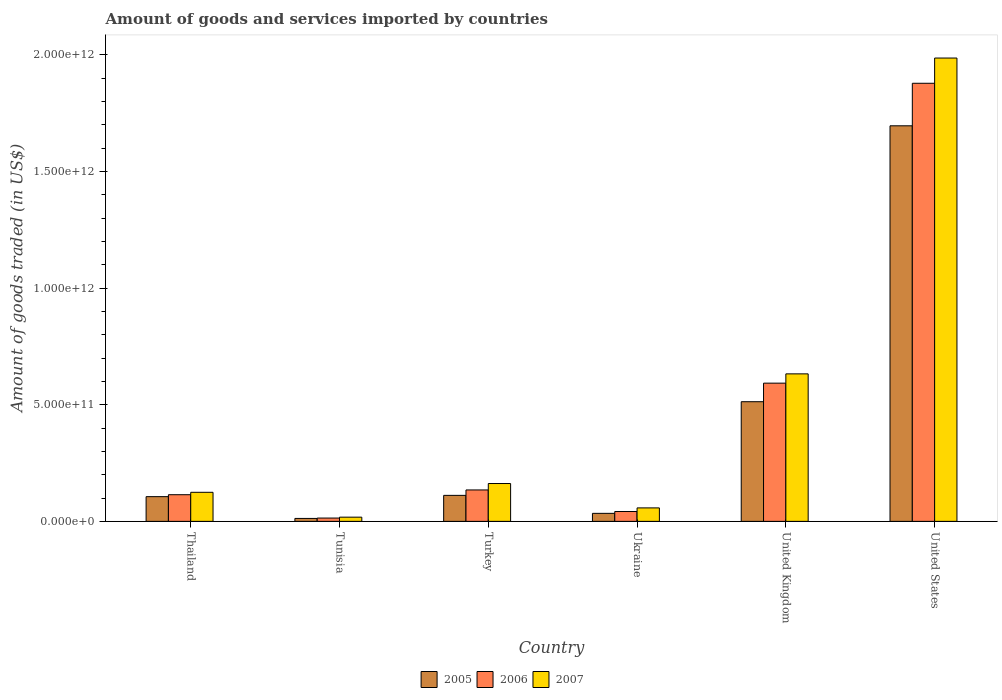How many different coloured bars are there?
Your answer should be compact. 3. Are the number of bars per tick equal to the number of legend labels?
Make the answer very short. Yes. How many bars are there on the 2nd tick from the right?
Provide a short and direct response. 3. What is the label of the 1st group of bars from the left?
Provide a short and direct response. Thailand. In how many cases, is the number of bars for a given country not equal to the number of legend labels?
Give a very brief answer. 0. What is the total amount of goods and services imported in 2007 in Ukraine?
Your response must be concise. 5.78e+1. Across all countries, what is the maximum total amount of goods and services imported in 2005?
Keep it short and to the point. 1.70e+12. Across all countries, what is the minimum total amount of goods and services imported in 2006?
Offer a very short reply. 1.42e+1. In which country was the total amount of goods and services imported in 2005 maximum?
Offer a very short reply. United States. In which country was the total amount of goods and services imported in 2007 minimum?
Your response must be concise. Tunisia. What is the total total amount of goods and services imported in 2007 in the graph?
Ensure brevity in your answer.  2.98e+12. What is the difference between the total amount of goods and services imported in 2007 in Thailand and that in United Kingdom?
Give a very brief answer. -5.08e+11. What is the difference between the total amount of goods and services imported in 2007 in United States and the total amount of goods and services imported in 2006 in Thailand?
Ensure brevity in your answer.  1.87e+12. What is the average total amount of goods and services imported in 2007 per country?
Your response must be concise. 4.97e+11. What is the difference between the total amount of goods and services imported of/in 2006 and total amount of goods and services imported of/in 2005 in United States?
Offer a terse response. 1.82e+11. In how many countries, is the total amount of goods and services imported in 2007 greater than 200000000000 US$?
Offer a terse response. 2. What is the ratio of the total amount of goods and services imported in 2006 in Thailand to that in United Kingdom?
Your response must be concise. 0.19. Is the total amount of goods and services imported in 2007 in Thailand less than that in Ukraine?
Provide a short and direct response. No. Is the difference between the total amount of goods and services imported in 2006 in Turkey and United States greater than the difference between the total amount of goods and services imported in 2005 in Turkey and United States?
Provide a short and direct response. No. What is the difference between the highest and the second highest total amount of goods and services imported in 2006?
Your response must be concise. 1.29e+12. What is the difference between the highest and the lowest total amount of goods and services imported in 2007?
Keep it short and to the point. 1.97e+12. In how many countries, is the total amount of goods and services imported in 2007 greater than the average total amount of goods and services imported in 2007 taken over all countries?
Keep it short and to the point. 2. Is the sum of the total amount of goods and services imported in 2007 in Tunisia and Turkey greater than the maximum total amount of goods and services imported in 2005 across all countries?
Your answer should be compact. No. What does the 3rd bar from the left in Thailand represents?
Provide a succinct answer. 2007. How many bars are there?
Your answer should be compact. 18. How many countries are there in the graph?
Make the answer very short. 6. What is the difference between two consecutive major ticks on the Y-axis?
Your answer should be compact. 5.00e+11. Are the values on the major ticks of Y-axis written in scientific E-notation?
Give a very brief answer. Yes. Does the graph contain grids?
Give a very brief answer. No. Where does the legend appear in the graph?
Give a very brief answer. Bottom center. What is the title of the graph?
Your response must be concise. Amount of goods and services imported by countries. What is the label or title of the Y-axis?
Ensure brevity in your answer.  Amount of goods traded (in US$). What is the Amount of goods traded (in US$) in 2005 in Thailand?
Your answer should be compact. 1.06e+11. What is the Amount of goods traded (in US$) in 2006 in Thailand?
Your response must be concise. 1.14e+11. What is the Amount of goods traded (in US$) of 2007 in Thailand?
Offer a very short reply. 1.25e+11. What is the Amount of goods traded (in US$) of 2005 in Tunisia?
Give a very brief answer. 1.26e+1. What is the Amount of goods traded (in US$) of 2006 in Tunisia?
Offer a terse response. 1.42e+1. What is the Amount of goods traded (in US$) in 2007 in Tunisia?
Keep it short and to the point. 1.80e+1. What is the Amount of goods traded (in US$) in 2005 in Turkey?
Provide a succinct answer. 1.11e+11. What is the Amount of goods traded (in US$) in 2006 in Turkey?
Your answer should be very brief. 1.35e+11. What is the Amount of goods traded (in US$) in 2007 in Turkey?
Your response must be concise. 1.62e+11. What is the Amount of goods traded (in US$) in 2005 in Ukraine?
Provide a short and direct response. 3.44e+1. What is the Amount of goods traded (in US$) of 2006 in Ukraine?
Offer a terse response. 4.22e+1. What is the Amount of goods traded (in US$) of 2007 in Ukraine?
Give a very brief answer. 5.78e+1. What is the Amount of goods traded (in US$) of 2005 in United Kingdom?
Your answer should be compact. 5.13e+11. What is the Amount of goods traded (in US$) in 2006 in United Kingdom?
Your answer should be compact. 5.93e+11. What is the Amount of goods traded (in US$) in 2007 in United Kingdom?
Ensure brevity in your answer.  6.32e+11. What is the Amount of goods traded (in US$) of 2005 in United States?
Your answer should be very brief. 1.70e+12. What is the Amount of goods traded (in US$) of 2006 in United States?
Give a very brief answer. 1.88e+12. What is the Amount of goods traded (in US$) of 2007 in United States?
Ensure brevity in your answer.  1.99e+12. Across all countries, what is the maximum Amount of goods traded (in US$) in 2005?
Provide a short and direct response. 1.70e+12. Across all countries, what is the maximum Amount of goods traded (in US$) in 2006?
Provide a succinct answer. 1.88e+12. Across all countries, what is the maximum Amount of goods traded (in US$) of 2007?
Make the answer very short. 1.99e+12. Across all countries, what is the minimum Amount of goods traded (in US$) of 2005?
Your answer should be compact. 1.26e+1. Across all countries, what is the minimum Amount of goods traded (in US$) in 2006?
Provide a succinct answer. 1.42e+1. Across all countries, what is the minimum Amount of goods traded (in US$) of 2007?
Ensure brevity in your answer.  1.80e+1. What is the total Amount of goods traded (in US$) of 2005 in the graph?
Ensure brevity in your answer.  2.47e+12. What is the total Amount of goods traded (in US$) of 2006 in the graph?
Give a very brief answer. 2.78e+12. What is the total Amount of goods traded (in US$) of 2007 in the graph?
Make the answer very short. 2.98e+12. What is the difference between the Amount of goods traded (in US$) in 2005 in Thailand and that in Tunisia?
Your response must be concise. 9.34e+1. What is the difference between the Amount of goods traded (in US$) of 2006 in Thailand and that in Tunisia?
Your response must be concise. 1.00e+11. What is the difference between the Amount of goods traded (in US$) of 2007 in Thailand and that in Tunisia?
Provide a short and direct response. 1.07e+11. What is the difference between the Amount of goods traded (in US$) in 2005 in Thailand and that in Turkey?
Make the answer very short. -5.47e+09. What is the difference between the Amount of goods traded (in US$) in 2006 in Thailand and that in Turkey?
Your answer should be compact. -2.04e+1. What is the difference between the Amount of goods traded (in US$) in 2007 in Thailand and that in Turkey?
Ensure brevity in your answer.  -3.76e+1. What is the difference between the Amount of goods traded (in US$) of 2005 in Thailand and that in Ukraine?
Ensure brevity in your answer.  7.16e+1. What is the difference between the Amount of goods traded (in US$) of 2006 in Thailand and that in Ukraine?
Your response must be concise. 7.20e+1. What is the difference between the Amount of goods traded (in US$) in 2007 in Thailand and that in Ukraine?
Make the answer very short. 6.69e+1. What is the difference between the Amount of goods traded (in US$) of 2005 in Thailand and that in United Kingdom?
Make the answer very short. -4.07e+11. What is the difference between the Amount of goods traded (in US$) of 2006 in Thailand and that in United Kingdom?
Provide a succinct answer. -4.78e+11. What is the difference between the Amount of goods traded (in US$) in 2007 in Thailand and that in United Kingdom?
Give a very brief answer. -5.08e+11. What is the difference between the Amount of goods traded (in US$) in 2005 in Thailand and that in United States?
Your response must be concise. -1.59e+12. What is the difference between the Amount of goods traded (in US$) of 2006 in Thailand and that in United States?
Offer a very short reply. -1.76e+12. What is the difference between the Amount of goods traded (in US$) of 2007 in Thailand and that in United States?
Make the answer very short. -1.86e+12. What is the difference between the Amount of goods traded (in US$) of 2005 in Tunisia and that in Turkey?
Provide a short and direct response. -9.89e+1. What is the difference between the Amount of goods traded (in US$) in 2006 in Tunisia and that in Turkey?
Provide a short and direct response. -1.20e+11. What is the difference between the Amount of goods traded (in US$) of 2007 in Tunisia and that in Turkey?
Give a very brief answer. -1.44e+11. What is the difference between the Amount of goods traded (in US$) in 2005 in Tunisia and that in Ukraine?
Your response must be concise. -2.18e+1. What is the difference between the Amount of goods traded (in US$) of 2006 in Tunisia and that in Ukraine?
Provide a succinct answer. -2.80e+1. What is the difference between the Amount of goods traded (in US$) of 2007 in Tunisia and that in Ukraine?
Give a very brief answer. -3.97e+1. What is the difference between the Amount of goods traded (in US$) of 2005 in Tunisia and that in United Kingdom?
Offer a terse response. -5.00e+11. What is the difference between the Amount of goods traded (in US$) in 2006 in Tunisia and that in United Kingdom?
Ensure brevity in your answer.  -5.78e+11. What is the difference between the Amount of goods traded (in US$) in 2007 in Tunisia and that in United Kingdom?
Your answer should be compact. -6.14e+11. What is the difference between the Amount of goods traded (in US$) in 2005 in Tunisia and that in United States?
Your answer should be compact. -1.68e+12. What is the difference between the Amount of goods traded (in US$) of 2006 in Tunisia and that in United States?
Offer a very short reply. -1.86e+12. What is the difference between the Amount of goods traded (in US$) in 2007 in Tunisia and that in United States?
Your answer should be compact. -1.97e+12. What is the difference between the Amount of goods traded (in US$) in 2005 in Turkey and that in Ukraine?
Offer a very short reply. 7.71e+1. What is the difference between the Amount of goods traded (in US$) of 2006 in Turkey and that in Ukraine?
Keep it short and to the point. 9.25e+1. What is the difference between the Amount of goods traded (in US$) of 2007 in Turkey and that in Ukraine?
Provide a short and direct response. 1.04e+11. What is the difference between the Amount of goods traded (in US$) of 2005 in Turkey and that in United Kingdom?
Offer a terse response. -4.02e+11. What is the difference between the Amount of goods traded (in US$) in 2006 in Turkey and that in United Kingdom?
Offer a terse response. -4.58e+11. What is the difference between the Amount of goods traded (in US$) in 2007 in Turkey and that in United Kingdom?
Offer a terse response. -4.70e+11. What is the difference between the Amount of goods traded (in US$) of 2005 in Turkey and that in United States?
Keep it short and to the point. -1.58e+12. What is the difference between the Amount of goods traded (in US$) of 2006 in Turkey and that in United States?
Ensure brevity in your answer.  -1.74e+12. What is the difference between the Amount of goods traded (in US$) in 2007 in Turkey and that in United States?
Provide a short and direct response. -1.82e+12. What is the difference between the Amount of goods traded (in US$) in 2005 in Ukraine and that in United Kingdom?
Ensure brevity in your answer.  -4.79e+11. What is the difference between the Amount of goods traded (in US$) in 2006 in Ukraine and that in United Kingdom?
Your answer should be compact. -5.50e+11. What is the difference between the Amount of goods traded (in US$) in 2007 in Ukraine and that in United Kingdom?
Make the answer very short. -5.75e+11. What is the difference between the Amount of goods traded (in US$) of 2005 in Ukraine and that in United States?
Ensure brevity in your answer.  -1.66e+12. What is the difference between the Amount of goods traded (in US$) of 2006 in Ukraine and that in United States?
Keep it short and to the point. -1.84e+12. What is the difference between the Amount of goods traded (in US$) of 2007 in Ukraine and that in United States?
Offer a very short reply. -1.93e+12. What is the difference between the Amount of goods traded (in US$) in 2005 in United Kingdom and that in United States?
Give a very brief answer. -1.18e+12. What is the difference between the Amount of goods traded (in US$) in 2006 in United Kingdom and that in United States?
Your answer should be compact. -1.29e+12. What is the difference between the Amount of goods traded (in US$) in 2007 in United Kingdom and that in United States?
Your answer should be very brief. -1.35e+12. What is the difference between the Amount of goods traded (in US$) in 2005 in Thailand and the Amount of goods traded (in US$) in 2006 in Tunisia?
Your response must be concise. 9.18e+1. What is the difference between the Amount of goods traded (in US$) in 2005 in Thailand and the Amount of goods traded (in US$) in 2007 in Tunisia?
Your answer should be very brief. 8.80e+1. What is the difference between the Amount of goods traded (in US$) of 2006 in Thailand and the Amount of goods traded (in US$) of 2007 in Tunisia?
Give a very brief answer. 9.62e+1. What is the difference between the Amount of goods traded (in US$) in 2005 in Thailand and the Amount of goods traded (in US$) in 2006 in Turkey?
Ensure brevity in your answer.  -2.87e+1. What is the difference between the Amount of goods traded (in US$) in 2005 in Thailand and the Amount of goods traded (in US$) in 2007 in Turkey?
Provide a succinct answer. -5.62e+1. What is the difference between the Amount of goods traded (in US$) of 2006 in Thailand and the Amount of goods traded (in US$) of 2007 in Turkey?
Ensure brevity in your answer.  -4.79e+1. What is the difference between the Amount of goods traded (in US$) of 2005 in Thailand and the Amount of goods traded (in US$) of 2006 in Ukraine?
Make the answer very short. 6.38e+1. What is the difference between the Amount of goods traded (in US$) of 2005 in Thailand and the Amount of goods traded (in US$) of 2007 in Ukraine?
Your answer should be compact. 4.82e+1. What is the difference between the Amount of goods traded (in US$) in 2006 in Thailand and the Amount of goods traded (in US$) in 2007 in Ukraine?
Ensure brevity in your answer.  5.65e+1. What is the difference between the Amount of goods traded (in US$) of 2005 in Thailand and the Amount of goods traded (in US$) of 2006 in United Kingdom?
Provide a short and direct response. -4.87e+11. What is the difference between the Amount of goods traded (in US$) of 2005 in Thailand and the Amount of goods traded (in US$) of 2007 in United Kingdom?
Your answer should be compact. -5.26e+11. What is the difference between the Amount of goods traded (in US$) in 2006 in Thailand and the Amount of goods traded (in US$) in 2007 in United Kingdom?
Offer a terse response. -5.18e+11. What is the difference between the Amount of goods traded (in US$) in 2005 in Thailand and the Amount of goods traded (in US$) in 2006 in United States?
Make the answer very short. -1.77e+12. What is the difference between the Amount of goods traded (in US$) of 2005 in Thailand and the Amount of goods traded (in US$) of 2007 in United States?
Provide a short and direct response. -1.88e+12. What is the difference between the Amount of goods traded (in US$) in 2006 in Thailand and the Amount of goods traded (in US$) in 2007 in United States?
Make the answer very short. -1.87e+12. What is the difference between the Amount of goods traded (in US$) of 2005 in Tunisia and the Amount of goods traded (in US$) of 2006 in Turkey?
Offer a terse response. -1.22e+11. What is the difference between the Amount of goods traded (in US$) of 2005 in Tunisia and the Amount of goods traded (in US$) of 2007 in Turkey?
Provide a short and direct response. -1.50e+11. What is the difference between the Amount of goods traded (in US$) in 2006 in Tunisia and the Amount of goods traded (in US$) in 2007 in Turkey?
Provide a short and direct response. -1.48e+11. What is the difference between the Amount of goods traded (in US$) in 2005 in Tunisia and the Amount of goods traded (in US$) in 2006 in Ukraine?
Give a very brief answer. -2.96e+1. What is the difference between the Amount of goods traded (in US$) in 2005 in Tunisia and the Amount of goods traded (in US$) in 2007 in Ukraine?
Make the answer very short. -4.52e+1. What is the difference between the Amount of goods traded (in US$) in 2006 in Tunisia and the Amount of goods traded (in US$) in 2007 in Ukraine?
Keep it short and to the point. -4.36e+1. What is the difference between the Amount of goods traded (in US$) in 2005 in Tunisia and the Amount of goods traded (in US$) in 2006 in United Kingdom?
Keep it short and to the point. -5.80e+11. What is the difference between the Amount of goods traded (in US$) of 2005 in Tunisia and the Amount of goods traded (in US$) of 2007 in United Kingdom?
Your response must be concise. -6.20e+11. What is the difference between the Amount of goods traded (in US$) in 2006 in Tunisia and the Amount of goods traded (in US$) in 2007 in United Kingdom?
Your answer should be very brief. -6.18e+11. What is the difference between the Amount of goods traded (in US$) in 2005 in Tunisia and the Amount of goods traded (in US$) in 2006 in United States?
Your answer should be compact. -1.87e+12. What is the difference between the Amount of goods traded (in US$) of 2005 in Tunisia and the Amount of goods traded (in US$) of 2007 in United States?
Give a very brief answer. -1.97e+12. What is the difference between the Amount of goods traded (in US$) in 2006 in Tunisia and the Amount of goods traded (in US$) in 2007 in United States?
Give a very brief answer. -1.97e+12. What is the difference between the Amount of goods traded (in US$) of 2005 in Turkey and the Amount of goods traded (in US$) of 2006 in Ukraine?
Make the answer very short. 6.92e+1. What is the difference between the Amount of goods traded (in US$) in 2005 in Turkey and the Amount of goods traded (in US$) in 2007 in Ukraine?
Make the answer very short. 5.37e+1. What is the difference between the Amount of goods traded (in US$) in 2006 in Turkey and the Amount of goods traded (in US$) in 2007 in Ukraine?
Ensure brevity in your answer.  7.69e+1. What is the difference between the Amount of goods traded (in US$) of 2005 in Turkey and the Amount of goods traded (in US$) of 2006 in United Kingdom?
Offer a very short reply. -4.81e+11. What is the difference between the Amount of goods traded (in US$) in 2005 in Turkey and the Amount of goods traded (in US$) in 2007 in United Kingdom?
Your response must be concise. -5.21e+11. What is the difference between the Amount of goods traded (in US$) of 2006 in Turkey and the Amount of goods traded (in US$) of 2007 in United Kingdom?
Provide a succinct answer. -4.98e+11. What is the difference between the Amount of goods traded (in US$) in 2005 in Turkey and the Amount of goods traded (in US$) in 2006 in United States?
Your response must be concise. -1.77e+12. What is the difference between the Amount of goods traded (in US$) in 2005 in Turkey and the Amount of goods traded (in US$) in 2007 in United States?
Give a very brief answer. -1.87e+12. What is the difference between the Amount of goods traded (in US$) in 2006 in Turkey and the Amount of goods traded (in US$) in 2007 in United States?
Ensure brevity in your answer.  -1.85e+12. What is the difference between the Amount of goods traded (in US$) of 2005 in Ukraine and the Amount of goods traded (in US$) of 2006 in United Kingdom?
Provide a short and direct response. -5.58e+11. What is the difference between the Amount of goods traded (in US$) of 2005 in Ukraine and the Amount of goods traded (in US$) of 2007 in United Kingdom?
Your response must be concise. -5.98e+11. What is the difference between the Amount of goods traded (in US$) in 2006 in Ukraine and the Amount of goods traded (in US$) in 2007 in United Kingdom?
Your answer should be compact. -5.90e+11. What is the difference between the Amount of goods traded (in US$) in 2005 in Ukraine and the Amount of goods traded (in US$) in 2006 in United States?
Ensure brevity in your answer.  -1.84e+12. What is the difference between the Amount of goods traded (in US$) of 2005 in Ukraine and the Amount of goods traded (in US$) of 2007 in United States?
Make the answer very short. -1.95e+12. What is the difference between the Amount of goods traded (in US$) of 2006 in Ukraine and the Amount of goods traded (in US$) of 2007 in United States?
Your answer should be very brief. -1.94e+12. What is the difference between the Amount of goods traded (in US$) in 2005 in United Kingdom and the Amount of goods traded (in US$) in 2006 in United States?
Make the answer very short. -1.37e+12. What is the difference between the Amount of goods traded (in US$) of 2005 in United Kingdom and the Amount of goods traded (in US$) of 2007 in United States?
Keep it short and to the point. -1.47e+12. What is the difference between the Amount of goods traded (in US$) of 2006 in United Kingdom and the Amount of goods traded (in US$) of 2007 in United States?
Ensure brevity in your answer.  -1.39e+12. What is the average Amount of goods traded (in US$) of 2005 per country?
Offer a very short reply. 4.12e+11. What is the average Amount of goods traded (in US$) in 2006 per country?
Give a very brief answer. 4.63e+11. What is the average Amount of goods traded (in US$) of 2007 per country?
Make the answer very short. 4.97e+11. What is the difference between the Amount of goods traded (in US$) in 2005 and Amount of goods traded (in US$) in 2006 in Thailand?
Your answer should be compact. -8.29e+09. What is the difference between the Amount of goods traded (in US$) in 2005 and Amount of goods traded (in US$) in 2007 in Thailand?
Offer a terse response. -1.86e+1. What is the difference between the Amount of goods traded (in US$) in 2006 and Amount of goods traded (in US$) in 2007 in Thailand?
Your answer should be very brief. -1.03e+1. What is the difference between the Amount of goods traded (in US$) of 2005 and Amount of goods traded (in US$) of 2006 in Tunisia?
Offer a very short reply. -1.61e+09. What is the difference between the Amount of goods traded (in US$) of 2005 and Amount of goods traded (in US$) of 2007 in Tunisia?
Your answer should be very brief. -5.43e+09. What is the difference between the Amount of goods traded (in US$) of 2006 and Amount of goods traded (in US$) of 2007 in Tunisia?
Keep it short and to the point. -3.82e+09. What is the difference between the Amount of goods traded (in US$) of 2005 and Amount of goods traded (in US$) of 2006 in Turkey?
Provide a short and direct response. -2.32e+1. What is the difference between the Amount of goods traded (in US$) in 2005 and Amount of goods traded (in US$) in 2007 in Turkey?
Your response must be concise. -5.08e+1. What is the difference between the Amount of goods traded (in US$) in 2006 and Amount of goods traded (in US$) in 2007 in Turkey?
Provide a succinct answer. -2.75e+1. What is the difference between the Amount of goods traded (in US$) in 2005 and Amount of goods traded (in US$) in 2006 in Ukraine?
Provide a short and direct response. -7.84e+09. What is the difference between the Amount of goods traded (in US$) in 2005 and Amount of goods traded (in US$) in 2007 in Ukraine?
Give a very brief answer. -2.34e+1. What is the difference between the Amount of goods traded (in US$) of 2006 and Amount of goods traded (in US$) of 2007 in Ukraine?
Your response must be concise. -1.55e+1. What is the difference between the Amount of goods traded (in US$) in 2005 and Amount of goods traded (in US$) in 2006 in United Kingdom?
Offer a terse response. -7.96e+1. What is the difference between the Amount of goods traded (in US$) of 2005 and Amount of goods traded (in US$) of 2007 in United Kingdom?
Provide a succinct answer. -1.19e+11. What is the difference between the Amount of goods traded (in US$) in 2006 and Amount of goods traded (in US$) in 2007 in United Kingdom?
Your response must be concise. -3.98e+1. What is the difference between the Amount of goods traded (in US$) of 2005 and Amount of goods traded (in US$) of 2006 in United States?
Offer a very short reply. -1.82e+11. What is the difference between the Amount of goods traded (in US$) in 2005 and Amount of goods traded (in US$) in 2007 in United States?
Give a very brief answer. -2.91e+11. What is the difference between the Amount of goods traded (in US$) of 2006 and Amount of goods traded (in US$) of 2007 in United States?
Your answer should be compact. -1.08e+11. What is the ratio of the Amount of goods traded (in US$) of 2005 in Thailand to that in Tunisia?
Provide a succinct answer. 8.41. What is the ratio of the Amount of goods traded (in US$) of 2006 in Thailand to that in Tunisia?
Offer a very short reply. 8.05. What is the ratio of the Amount of goods traded (in US$) of 2007 in Thailand to that in Tunisia?
Make the answer very short. 6.91. What is the ratio of the Amount of goods traded (in US$) in 2005 in Thailand to that in Turkey?
Make the answer very short. 0.95. What is the ratio of the Amount of goods traded (in US$) in 2006 in Thailand to that in Turkey?
Give a very brief answer. 0.85. What is the ratio of the Amount of goods traded (in US$) of 2007 in Thailand to that in Turkey?
Provide a succinct answer. 0.77. What is the ratio of the Amount of goods traded (in US$) in 2005 in Thailand to that in Ukraine?
Provide a succinct answer. 3.08. What is the ratio of the Amount of goods traded (in US$) in 2006 in Thailand to that in Ukraine?
Your answer should be compact. 2.71. What is the ratio of the Amount of goods traded (in US$) of 2007 in Thailand to that in Ukraine?
Provide a succinct answer. 2.16. What is the ratio of the Amount of goods traded (in US$) of 2005 in Thailand to that in United Kingdom?
Make the answer very short. 0.21. What is the ratio of the Amount of goods traded (in US$) in 2006 in Thailand to that in United Kingdom?
Your response must be concise. 0.19. What is the ratio of the Amount of goods traded (in US$) of 2007 in Thailand to that in United Kingdom?
Provide a short and direct response. 0.2. What is the ratio of the Amount of goods traded (in US$) in 2005 in Thailand to that in United States?
Provide a succinct answer. 0.06. What is the ratio of the Amount of goods traded (in US$) in 2006 in Thailand to that in United States?
Provide a short and direct response. 0.06. What is the ratio of the Amount of goods traded (in US$) of 2007 in Thailand to that in United States?
Provide a succinct answer. 0.06. What is the ratio of the Amount of goods traded (in US$) of 2005 in Tunisia to that in Turkey?
Provide a succinct answer. 0.11. What is the ratio of the Amount of goods traded (in US$) of 2006 in Tunisia to that in Turkey?
Offer a terse response. 0.11. What is the ratio of the Amount of goods traded (in US$) in 2007 in Tunisia to that in Turkey?
Offer a very short reply. 0.11. What is the ratio of the Amount of goods traded (in US$) in 2005 in Tunisia to that in Ukraine?
Provide a short and direct response. 0.37. What is the ratio of the Amount of goods traded (in US$) in 2006 in Tunisia to that in Ukraine?
Ensure brevity in your answer.  0.34. What is the ratio of the Amount of goods traded (in US$) in 2007 in Tunisia to that in Ukraine?
Ensure brevity in your answer.  0.31. What is the ratio of the Amount of goods traded (in US$) of 2005 in Tunisia to that in United Kingdom?
Keep it short and to the point. 0.02. What is the ratio of the Amount of goods traded (in US$) of 2006 in Tunisia to that in United Kingdom?
Offer a very short reply. 0.02. What is the ratio of the Amount of goods traded (in US$) of 2007 in Tunisia to that in United Kingdom?
Give a very brief answer. 0.03. What is the ratio of the Amount of goods traded (in US$) in 2005 in Tunisia to that in United States?
Your answer should be very brief. 0.01. What is the ratio of the Amount of goods traded (in US$) in 2006 in Tunisia to that in United States?
Give a very brief answer. 0.01. What is the ratio of the Amount of goods traded (in US$) of 2007 in Tunisia to that in United States?
Offer a very short reply. 0.01. What is the ratio of the Amount of goods traded (in US$) in 2005 in Turkey to that in Ukraine?
Keep it short and to the point. 3.24. What is the ratio of the Amount of goods traded (in US$) of 2006 in Turkey to that in Ukraine?
Your response must be concise. 3.19. What is the ratio of the Amount of goods traded (in US$) in 2007 in Turkey to that in Ukraine?
Ensure brevity in your answer.  2.81. What is the ratio of the Amount of goods traded (in US$) in 2005 in Turkey to that in United Kingdom?
Your response must be concise. 0.22. What is the ratio of the Amount of goods traded (in US$) in 2006 in Turkey to that in United Kingdom?
Offer a very short reply. 0.23. What is the ratio of the Amount of goods traded (in US$) in 2007 in Turkey to that in United Kingdom?
Your answer should be very brief. 0.26. What is the ratio of the Amount of goods traded (in US$) of 2005 in Turkey to that in United States?
Offer a terse response. 0.07. What is the ratio of the Amount of goods traded (in US$) in 2006 in Turkey to that in United States?
Make the answer very short. 0.07. What is the ratio of the Amount of goods traded (in US$) of 2007 in Turkey to that in United States?
Make the answer very short. 0.08. What is the ratio of the Amount of goods traded (in US$) of 2005 in Ukraine to that in United Kingdom?
Provide a short and direct response. 0.07. What is the ratio of the Amount of goods traded (in US$) of 2006 in Ukraine to that in United Kingdom?
Provide a succinct answer. 0.07. What is the ratio of the Amount of goods traded (in US$) of 2007 in Ukraine to that in United Kingdom?
Make the answer very short. 0.09. What is the ratio of the Amount of goods traded (in US$) in 2005 in Ukraine to that in United States?
Ensure brevity in your answer.  0.02. What is the ratio of the Amount of goods traded (in US$) of 2006 in Ukraine to that in United States?
Provide a succinct answer. 0.02. What is the ratio of the Amount of goods traded (in US$) of 2007 in Ukraine to that in United States?
Your answer should be compact. 0.03. What is the ratio of the Amount of goods traded (in US$) in 2005 in United Kingdom to that in United States?
Give a very brief answer. 0.3. What is the ratio of the Amount of goods traded (in US$) in 2006 in United Kingdom to that in United States?
Make the answer very short. 0.32. What is the ratio of the Amount of goods traded (in US$) in 2007 in United Kingdom to that in United States?
Give a very brief answer. 0.32. What is the difference between the highest and the second highest Amount of goods traded (in US$) of 2005?
Your answer should be compact. 1.18e+12. What is the difference between the highest and the second highest Amount of goods traded (in US$) in 2006?
Provide a short and direct response. 1.29e+12. What is the difference between the highest and the second highest Amount of goods traded (in US$) in 2007?
Offer a very short reply. 1.35e+12. What is the difference between the highest and the lowest Amount of goods traded (in US$) in 2005?
Ensure brevity in your answer.  1.68e+12. What is the difference between the highest and the lowest Amount of goods traded (in US$) of 2006?
Your answer should be very brief. 1.86e+12. What is the difference between the highest and the lowest Amount of goods traded (in US$) of 2007?
Offer a terse response. 1.97e+12. 